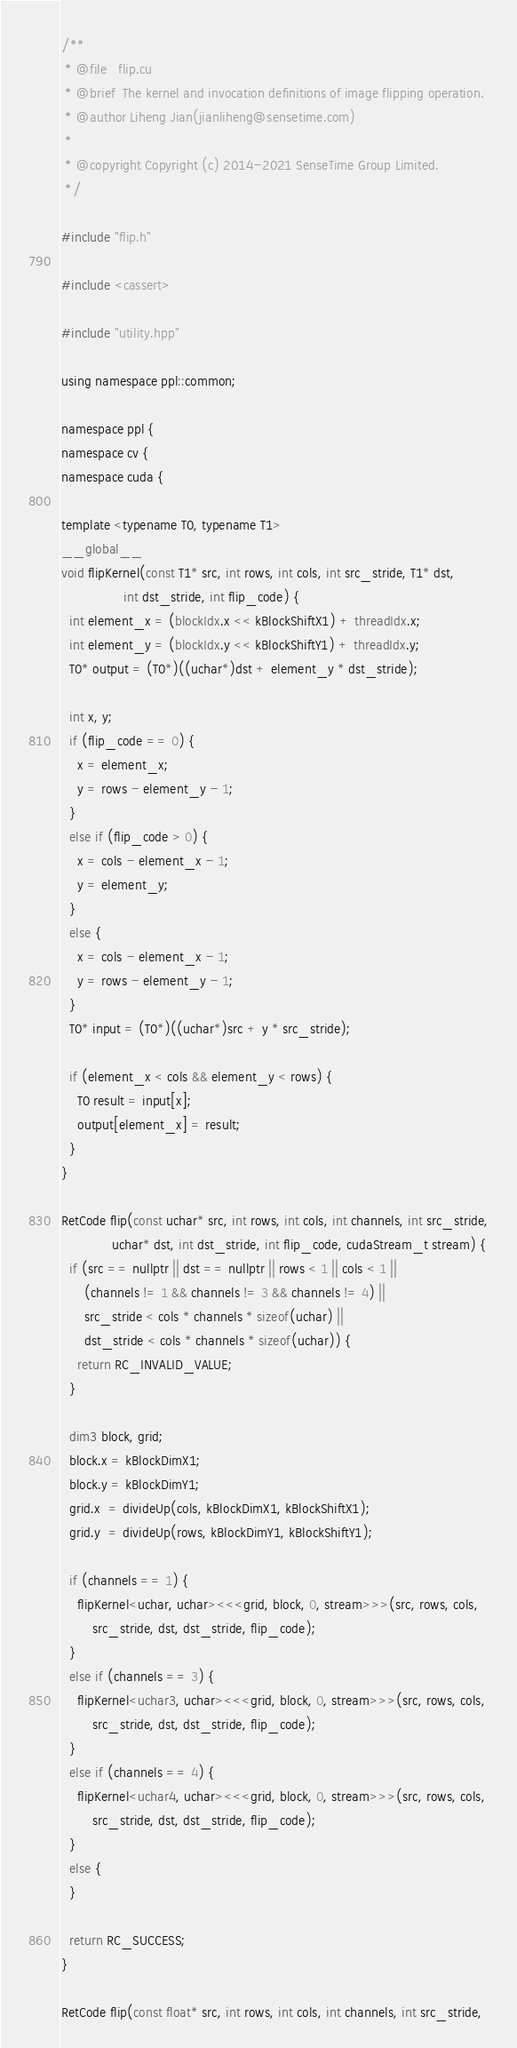<code> <loc_0><loc_0><loc_500><loc_500><_Cuda_>/**
 * @file   flip.cu
 * @brief  The kernel and invocation definitions of image flipping operation.
 * @author Liheng Jian(jianliheng@sensetime.com)
 *
 * @copyright Copyright (c) 2014-2021 SenseTime Group Limited.
 */

#include "flip.h"

#include <cassert>

#include "utility.hpp"

using namespace ppl::common;

namespace ppl {
namespace cv {
namespace cuda {

template <typename T0, typename T1>
__global__
void flipKernel(const T1* src, int rows, int cols, int src_stride, T1* dst,
                int dst_stride, int flip_code) {
  int element_x = (blockIdx.x << kBlockShiftX1) + threadIdx.x;
  int element_y = (blockIdx.y << kBlockShiftY1) + threadIdx.y;
  T0* output = (T0*)((uchar*)dst + element_y * dst_stride);

  int x, y;
  if (flip_code == 0) {
    x = element_x;
    y = rows - element_y - 1;
  }
  else if (flip_code > 0) {
    x = cols - element_x - 1;
    y = element_y;
  }
  else {
    x = cols - element_x - 1;
    y = rows - element_y - 1;
  }
  T0* input = (T0*)((uchar*)src + y * src_stride);

  if (element_x < cols && element_y < rows) {
    T0 result = input[x];
    output[element_x] = result;
  }
}

RetCode flip(const uchar* src, int rows, int cols, int channels, int src_stride,
             uchar* dst, int dst_stride, int flip_code, cudaStream_t stream) {
  if (src == nullptr || dst == nullptr || rows < 1 || cols < 1 ||
      (channels != 1 && channels != 3 && channels != 4) ||
      src_stride < cols * channels * sizeof(uchar) ||
      dst_stride < cols * channels * sizeof(uchar)) {
    return RC_INVALID_VALUE;
  }

  dim3 block, grid;
  block.x = kBlockDimX1;
  block.y = kBlockDimY1;
  grid.x  = divideUp(cols, kBlockDimX1, kBlockShiftX1);
  grid.y  = divideUp(rows, kBlockDimY1, kBlockShiftY1);

  if (channels == 1) {
    flipKernel<uchar, uchar><<<grid, block, 0, stream>>>(src, rows, cols,
        src_stride, dst, dst_stride, flip_code);
  }
  else if (channels == 3) {
    flipKernel<uchar3, uchar><<<grid, block, 0, stream>>>(src, rows, cols,
        src_stride, dst, dst_stride, flip_code);
  }
  else if (channels == 4) {
    flipKernel<uchar4, uchar><<<grid, block, 0, stream>>>(src, rows, cols,
        src_stride, dst, dst_stride, flip_code);
  }
  else {
  }

  return RC_SUCCESS;
}

RetCode flip(const float* src, int rows, int cols, int channels, int src_stride,</code> 